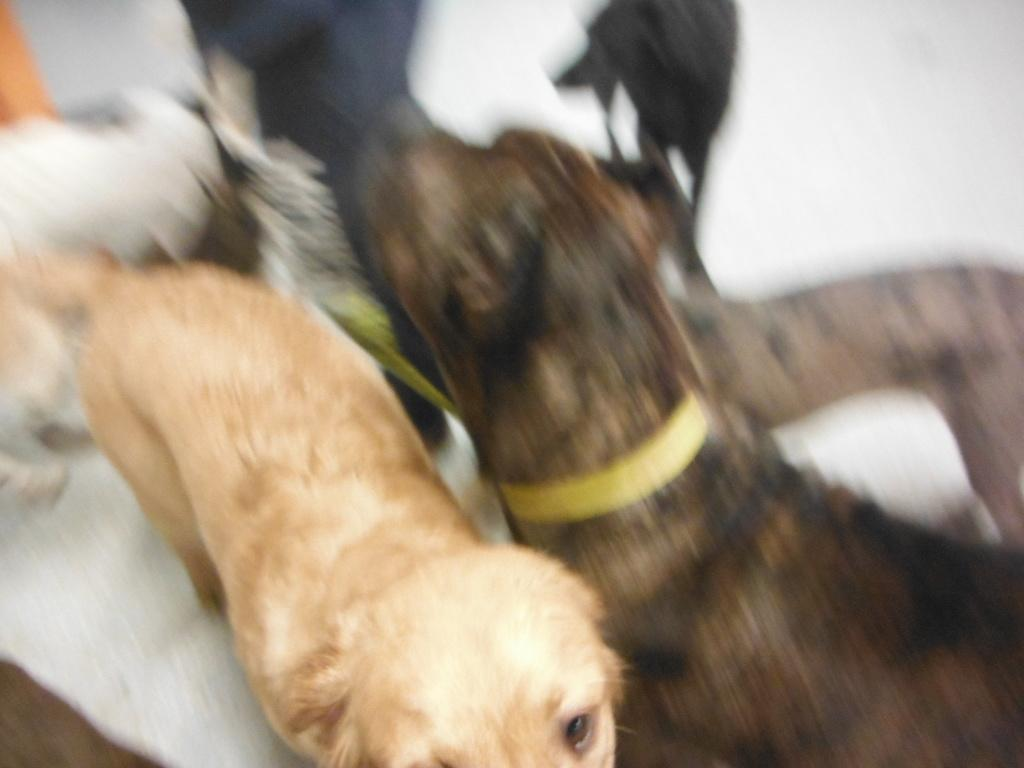What type of animals are present in the image? There are dogs in the image. Can you describe the background of the image? The background of the image is blurred. What type of apple is being held by the dog's dad in the image? There is no apple or dog's dad present in the image. On which side of the dog is the apple placed in the image? There is no apple present in the image. 